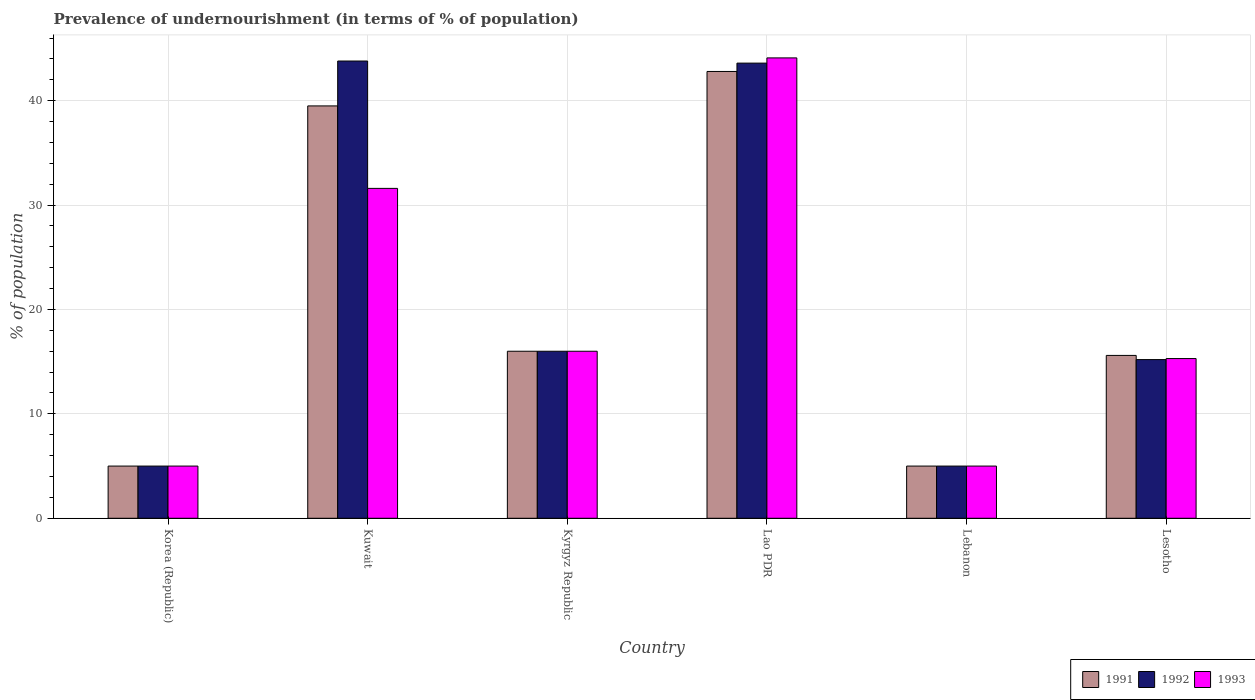Are the number of bars per tick equal to the number of legend labels?
Keep it short and to the point. Yes. Are the number of bars on each tick of the X-axis equal?
Your response must be concise. Yes. How many bars are there on the 2nd tick from the left?
Your answer should be very brief. 3. What is the label of the 2nd group of bars from the left?
Provide a succinct answer. Kuwait. What is the percentage of undernourished population in 1992 in Kuwait?
Provide a succinct answer. 43.8. Across all countries, what is the maximum percentage of undernourished population in 1991?
Offer a terse response. 42.8. Across all countries, what is the minimum percentage of undernourished population in 1993?
Ensure brevity in your answer.  5. In which country was the percentage of undernourished population in 1991 maximum?
Offer a terse response. Lao PDR. In which country was the percentage of undernourished population in 1993 minimum?
Your answer should be compact. Korea (Republic). What is the total percentage of undernourished population in 1992 in the graph?
Keep it short and to the point. 128.6. What is the difference between the percentage of undernourished population in 1991 in Lao PDR and that in Lebanon?
Ensure brevity in your answer.  37.8. What is the difference between the percentage of undernourished population in 1991 in Lao PDR and the percentage of undernourished population in 1992 in Lebanon?
Ensure brevity in your answer.  37.8. What is the average percentage of undernourished population in 1993 per country?
Your response must be concise. 19.5. What is the difference between the percentage of undernourished population of/in 1993 and percentage of undernourished population of/in 1992 in Lao PDR?
Make the answer very short. 0.5. In how many countries, is the percentage of undernourished population in 1991 greater than 2 %?
Give a very brief answer. 6. What is the ratio of the percentage of undernourished population in 1992 in Lebanon to that in Lesotho?
Make the answer very short. 0.33. What is the difference between the highest and the second highest percentage of undernourished population in 1993?
Your answer should be compact. -28.1. What is the difference between the highest and the lowest percentage of undernourished population in 1991?
Keep it short and to the point. 37.8. Is the sum of the percentage of undernourished population in 1993 in Kuwait and Lao PDR greater than the maximum percentage of undernourished population in 1991 across all countries?
Your answer should be very brief. Yes. What does the 2nd bar from the left in Lebanon represents?
Offer a terse response. 1992. What does the 3rd bar from the right in Lao PDR represents?
Make the answer very short. 1991. Is it the case that in every country, the sum of the percentage of undernourished population in 1993 and percentage of undernourished population in 1991 is greater than the percentage of undernourished population in 1992?
Make the answer very short. Yes. What is the difference between two consecutive major ticks on the Y-axis?
Provide a succinct answer. 10. Are the values on the major ticks of Y-axis written in scientific E-notation?
Give a very brief answer. No. Does the graph contain grids?
Your response must be concise. Yes. What is the title of the graph?
Offer a very short reply. Prevalence of undernourishment (in terms of % of population). Does "1989" appear as one of the legend labels in the graph?
Your response must be concise. No. What is the label or title of the X-axis?
Give a very brief answer. Country. What is the label or title of the Y-axis?
Keep it short and to the point. % of population. What is the % of population in 1991 in Korea (Republic)?
Your response must be concise. 5. What is the % of population in 1991 in Kuwait?
Offer a terse response. 39.5. What is the % of population in 1992 in Kuwait?
Keep it short and to the point. 43.8. What is the % of population in 1993 in Kuwait?
Offer a very short reply. 31.6. What is the % of population of 1991 in Lao PDR?
Make the answer very short. 42.8. What is the % of population in 1992 in Lao PDR?
Offer a terse response. 43.6. What is the % of population in 1993 in Lao PDR?
Keep it short and to the point. 44.1. What is the % of population of 1993 in Lebanon?
Ensure brevity in your answer.  5. What is the % of population of 1991 in Lesotho?
Provide a short and direct response. 15.6. Across all countries, what is the maximum % of population of 1991?
Keep it short and to the point. 42.8. Across all countries, what is the maximum % of population in 1992?
Provide a short and direct response. 43.8. Across all countries, what is the maximum % of population of 1993?
Offer a very short reply. 44.1. Across all countries, what is the minimum % of population of 1991?
Provide a succinct answer. 5. Across all countries, what is the minimum % of population of 1992?
Make the answer very short. 5. What is the total % of population of 1991 in the graph?
Make the answer very short. 123.9. What is the total % of population of 1992 in the graph?
Keep it short and to the point. 128.6. What is the total % of population in 1993 in the graph?
Provide a succinct answer. 117. What is the difference between the % of population of 1991 in Korea (Republic) and that in Kuwait?
Ensure brevity in your answer.  -34.5. What is the difference between the % of population in 1992 in Korea (Republic) and that in Kuwait?
Your answer should be compact. -38.8. What is the difference between the % of population in 1993 in Korea (Republic) and that in Kuwait?
Provide a succinct answer. -26.6. What is the difference between the % of population of 1992 in Korea (Republic) and that in Kyrgyz Republic?
Make the answer very short. -11. What is the difference between the % of population in 1993 in Korea (Republic) and that in Kyrgyz Republic?
Make the answer very short. -11. What is the difference between the % of population in 1991 in Korea (Republic) and that in Lao PDR?
Offer a terse response. -37.8. What is the difference between the % of population of 1992 in Korea (Republic) and that in Lao PDR?
Give a very brief answer. -38.6. What is the difference between the % of population of 1993 in Korea (Republic) and that in Lao PDR?
Give a very brief answer. -39.1. What is the difference between the % of population of 1992 in Korea (Republic) and that in Lebanon?
Keep it short and to the point. 0. What is the difference between the % of population of 1993 in Korea (Republic) and that in Lebanon?
Your answer should be compact. 0. What is the difference between the % of population in 1991 in Korea (Republic) and that in Lesotho?
Offer a terse response. -10.6. What is the difference between the % of population in 1992 in Korea (Republic) and that in Lesotho?
Your response must be concise. -10.2. What is the difference between the % of population in 1993 in Korea (Republic) and that in Lesotho?
Provide a succinct answer. -10.3. What is the difference between the % of population in 1991 in Kuwait and that in Kyrgyz Republic?
Give a very brief answer. 23.5. What is the difference between the % of population in 1992 in Kuwait and that in Kyrgyz Republic?
Make the answer very short. 27.8. What is the difference between the % of population in 1992 in Kuwait and that in Lao PDR?
Provide a succinct answer. 0.2. What is the difference between the % of population in 1993 in Kuwait and that in Lao PDR?
Offer a terse response. -12.5. What is the difference between the % of population of 1991 in Kuwait and that in Lebanon?
Offer a very short reply. 34.5. What is the difference between the % of population in 1992 in Kuwait and that in Lebanon?
Your response must be concise. 38.8. What is the difference between the % of population in 1993 in Kuwait and that in Lebanon?
Keep it short and to the point. 26.6. What is the difference between the % of population in 1991 in Kuwait and that in Lesotho?
Offer a terse response. 23.9. What is the difference between the % of population in 1992 in Kuwait and that in Lesotho?
Offer a very short reply. 28.6. What is the difference between the % of population of 1993 in Kuwait and that in Lesotho?
Provide a short and direct response. 16.3. What is the difference between the % of population of 1991 in Kyrgyz Republic and that in Lao PDR?
Make the answer very short. -26.8. What is the difference between the % of population of 1992 in Kyrgyz Republic and that in Lao PDR?
Your answer should be compact. -27.6. What is the difference between the % of population in 1993 in Kyrgyz Republic and that in Lao PDR?
Give a very brief answer. -28.1. What is the difference between the % of population in 1991 in Kyrgyz Republic and that in Lebanon?
Your answer should be compact. 11. What is the difference between the % of population in 1993 in Kyrgyz Republic and that in Lebanon?
Ensure brevity in your answer.  11. What is the difference between the % of population in 1991 in Kyrgyz Republic and that in Lesotho?
Offer a very short reply. 0.4. What is the difference between the % of population of 1993 in Kyrgyz Republic and that in Lesotho?
Your response must be concise. 0.7. What is the difference between the % of population in 1991 in Lao PDR and that in Lebanon?
Provide a succinct answer. 37.8. What is the difference between the % of population in 1992 in Lao PDR and that in Lebanon?
Make the answer very short. 38.6. What is the difference between the % of population of 1993 in Lao PDR and that in Lebanon?
Offer a terse response. 39.1. What is the difference between the % of population in 1991 in Lao PDR and that in Lesotho?
Keep it short and to the point. 27.2. What is the difference between the % of population of 1992 in Lao PDR and that in Lesotho?
Offer a terse response. 28.4. What is the difference between the % of population of 1993 in Lao PDR and that in Lesotho?
Your answer should be compact. 28.8. What is the difference between the % of population in 1991 in Korea (Republic) and the % of population in 1992 in Kuwait?
Your answer should be very brief. -38.8. What is the difference between the % of population of 1991 in Korea (Republic) and the % of population of 1993 in Kuwait?
Your response must be concise. -26.6. What is the difference between the % of population of 1992 in Korea (Republic) and the % of population of 1993 in Kuwait?
Offer a terse response. -26.6. What is the difference between the % of population of 1991 in Korea (Republic) and the % of population of 1992 in Kyrgyz Republic?
Give a very brief answer. -11. What is the difference between the % of population of 1991 in Korea (Republic) and the % of population of 1993 in Kyrgyz Republic?
Provide a short and direct response. -11. What is the difference between the % of population of 1991 in Korea (Republic) and the % of population of 1992 in Lao PDR?
Give a very brief answer. -38.6. What is the difference between the % of population of 1991 in Korea (Republic) and the % of population of 1993 in Lao PDR?
Ensure brevity in your answer.  -39.1. What is the difference between the % of population in 1992 in Korea (Republic) and the % of population in 1993 in Lao PDR?
Give a very brief answer. -39.1. What is the difference between the % of population of 1991 in Korea (Republic) and the % of population of 1993 in Lebanon?
Offer a terse response. 0. What is the difference between the % of population of 1992 in Korea (Republic) and the % of population of 1993 in Lebanon?
Your answer should be compact. 0. What is the difference between the % of population in 1991 in Korea (Republic) and the % of population in 1992 in Lesotho?
Keep it short and to the point. -10.2. What is the difference between the % of population of 1992 in Korea (Republic) and the % of population of 1993 in Lesotho?
Provide a succinct answer. -10.3. What is the difference between the % of population of 1991 in Kuwait and the % of population of 1993 in Kyrgyz Republic?
Ensure brevity in your answer.  23.5. What is the difference between the % of population of 1992 in Kuwait and the % of population of 1993 in Kyrgyz Republic?
Your answer should be very brief. 27.8. What is the difference between the % of population in 1991 in Kuwait and the % of population in 1992 in Lao PDR?
Provide a succinct answer. -4.1. What is the difference between the % of population of 1991 in Kuwait and the % of population of 1993 in Lao PDR?
Offer a very short reply. -4.6. What is the difference between the % of population of 1991 in Kuwait and the % of population of 1992 in Lebanon?
Provide a short and direct response. 34.5. What is the difference between the % of population of 1991 in Kuwait and the % of population of 1993 in Lebanon?
Offer a terse response. 34.5. What is the difference between the % of population in 1992 in Kuwait and the % of population in 1993 in Lebanon?
Give a very brief answer. 38.8. What is the difference between the % of population of 1991 in Kuwait and the % of population of 1992 in Lesotho?
Offer a terse response. 24.3. What is the difference between the % of population in 1991 in Kuwait and the % of population in 1993 in Lesotho?
Ensure brevity in your answer.  24.2. What is the difference between the % of population in 1992 in Kuwait and the % of population in 1993 in Lesotho?
Ensure brevity in your answer.  28.5. What is the difference between the % of population of 1991 in Kyrgyz Republic and the % of population of 1992 in Lao PDR?
Make the answer very short. -27.6. What is the difference between the % of population of 1991 in Kyrgyz Republic and the % of population of 1993 in Lao PDR?
Your response must be concise. -28.1. What is the difference between the % of population in 1992 in Kyrgyz Republic and the % of population in 1993 in Lao PDR?
Your answer should be very brief. -28.1. What is the difference between the % of population of 1992 in Kyrgyz Republic and the % of population of 1993 in Lebanon?
Your answer should be compact. 11. What is the difference between the % of population in 1992 in Kyrgyz Republic and the % of population in 1993 in Lesotho?
Your answer should be compact. 0.7. What is the difference between the % of population in 1991 in Lao PDR and the % of population in 1992 in Lebanon?
Offer a very short reply. 37.8. What is the difference between the % of population in 1991 in Lao PDR and the % of population in 1993 in Lebanon?
Your response must be concise. 37.8. What is the difference between the % of population in 1992 in Lao PDR and the % of population in 1993 in Lebanon?
Make the answer very short. 38.6. What is the difference between the % of population of 1991 in Lao PDR and the % of population of 1992 in Lesotho?
Your answer should be compact. 27.6. What is the difference between the % of population of 1991 in Lao PDR and the % of population of 1993 in Lesotho?
Give a very brief answer. 27.5. What is the difference between the % of population in 1992 in Lao PDR and the % of population in 1993 in Lesotho?
Make the answer very short. 28.3. What is the average % of population in 1991 per country?
Keep it short and to the point. 20.65. What is the average % of population in 1992 per country?
Provide a succinct answer. 21.43. What is the average % of population in 1993 per country?
Ensure brevity in your answer.  19.5. What is the difference between the % of population of 1991 and % of population of 1993 in Korea (Republic)?
Your answer should be compact. 0. What is the difference between the % of population of 1992 and % of population of 1993 in Korea (Republic)?
Provide a succinct answer. 0. What is the difference between the % of population in 1992 and % of population in 1993 in Kuwait?
Give a very brief answer. 12.2. What is the difference between the % of population of 1991 and % of population of 1992 in Kyrgyz Republic?
Provide a short and direct response. 0. What is the difference between the % of population in 1992 and % of population in 1993 in Kyrgyz Republic?
Offer a very short reply. 0. What is the difference between the % of population in 1991 and % of population in 1992 in Lao PDR?
Provide a succinct answer. -0.8. What is the difference between the % of population of 1991 and % of population of 1992 in Lebanon?
Give a very brief answer. 0. What is the difference between the % of population in 1991 and % of population in 1993 in Lebanon?
Make the answer very short. 0. What is the difference between the % of population of 1991 and % of population of 1992 in Lesotho?
Make the answer very short. 0.4. What is the difference between the % of population in 1992 and % of population in 1993 in Lesotho?
Offer a terse response. -0.1. What is the ratio of the % of population in 1991 in Korea (Republic) to that in Kuwait?
Make the answer very short. 0.13. What is the ratio of the % of population in 1992 in Korea (Republic) to that in Kuwait?
Provide a succinct answer. 0.11. What is the ratio of the % of population of 1993 in Korea (Republic) to that in Kuwait?
Your answer should be very brief. 0.16. What is the ratio of the % of population in 1991 in Korea (Republic) to that in Kyrgyz Republic?
Provide a short and direct response. 0.31. What is the ratio of the % of population in 1992 in Korea (Republic) to that in Kyrgyz Republic?
Provide a succinct answer. 0.31. What is the ratio of the % of population in 1993 in Korea (Republic) to that in Kyrgyz Republic?
Give a very brief answer. 0.31. What is the ratio of the % of population in 1991 in Korea (Republic) to that in Lao PDR?
Offer a very short reply. 0.12. What is the ratio of the % of population in 1992 in Korea (Republic) to that in Lao PDR?
Ensure brevity in your answer.  0.11. What is the ratio of the % of population in 1993 in Korea (Republic) to that in Lao PDR?
Provide a short and direct response. 0.11. What is the ratio of the % of population in 1991 in Korea (Republic) to that in Lebanon?
Keep it short and to the point. 1. What is the ratio of the % of population of 1992 in Korea (Republic) to that in Lebanon?
Provide a succinct answer. 1. What is the ratio of the % of population in 1991 in Korea (Republic) to that in Lesotho?
Offer a very short reply. 0.32. What is the ratio of the % of population in 1992 in Korea (Republic) to that in Lesotho?
Keep it short and to the point. 0.33. What is the ratio of the % of population in 1993 in Korea (Republic) to that in Lesotho?
Your answer should be compact. 0.33. What is the ratio of the % of population of 1991 in Kuwait to that in Kyrgyz Republic?
Your response must be concise. 2.47. What is the ratio of the % of population of 1992 in Kuwait to that in Kyrgyz Republic?
Make the answer very short. 2.74. What is the ratio of the % of population of 1993 in Kuwait to that in Kyrgyz Republic?
Keep it short and to the point. 1.98. What is the ratio of the % of population of 1991 in Kuwait to that in Lao PDR?
Your answer should be compact. 0.92. What is the ratio of the % of population of 1993 in Kuwait to that in Lao PDR?
Offer a terse response. 0.72. What is the ratio of the % of population in 1991 in Kuwait to that in Lebanon?
Make the answer very short. 7.9. What is the ratio of the % of population in 1992 in Kuwait to that in Lebanon?
Offer a very short reply. 8.76. What is the ratio of the % of population of 1993 in Kuwait to that in Lebanon?
Provide a succinct answer. 6.32. What is the ratio of the % of population in 1991 in Kuwait to that in Lesotho?
Ensure brevity in your answer.  2.53. What is the ratio of the % of population in 1992 in Kuwait to that in Lesotho?
Your answer should be very brief. 2.88. What is the ratio of the % of population in 1993 in Kuwait to that in Lesotho?
Offer a terse response. 2.07. What is the ratio of the % of population of 1991 in Kyrgyz Republic to that in Lao PDR?
Provide a succinct answer. 0.37. What is the ratio of the % of population of 1992 in Kyrgyz Republic to that in Lao PDR?
Keep it short and to the point. 0.37. What is the ratio of the % of population of 1993 in Kyrgyz Republic to that in Lao PDR?
Ensure brevity in your answer.  0.36. What is the ratio of the % of population in 1991 in Kyrgyz Republic to that in Lebanon?
Your answer should be very brief. 3.2. What is the ratio of the % of population of 1993 in Kyrgyz Republic to that in Lebanon?
Your answer should be very brief. 3.2. What is the ratio of the % of population in 1991 in Kyrgyz Republic to that in Lesotho?
Offer a very short reply. 1.03. What is the ratio of the % of population in 1992 in Kyrgyz Republic to that in Lesotho?
Your answer should be very brief. 1.05. What is the ratio of the % of population of 1993 in Kyrgyz Republic to that in Lesotho?
Your answer should be very brief. 1.05. What is the ratio of the % of population in 1991 in Lao PDR to that in Lebanon?
Make the answer very short. 8.56. What is the ratio of the % of population of 1992 in Lao PDR to that in Lebanon?
Make the answer very short. 8.72. What is the ratio of the % of population in 1993 in Lao PDR to that in Lebanon?
Offer a very short reply. 8.82. What is the ratio of the % of population of 1991 in Lao PDR to that in Lesotho?
Your response must be concise. 2.74. What is the ratio of the % of population of 1992 in Lao PDR to that in Lesotho?
Your answer should be compact. 2.87. What is the ratio of the % of population of 1993 in Lao PDR to that in Lesotho?
Provide a short and direct response. 2.88. What is the ratio of the % of population of 1991 in Lebanon to that in Lesotho?
Provide a succinct answer. 0.32. What is the ratio of the % of population of 1992 in Lebanon to that in Lesotho?
Give a very brief answer. 0.33. What is the ratio of the % of population of 1993 in Lebanon to that in Lesotho?
Give a very brief answer. 0.33. What is the difference between the highest and the lowest % of population of 1991?
Your response must be concise. 37.8. What is the difference between the highest and the lowest % of population in 1992?
Provide a succinct answer. 38.8. What is the difference between the highest and the lowest % of population in 1993?
Make the answer very short. 39.1. 